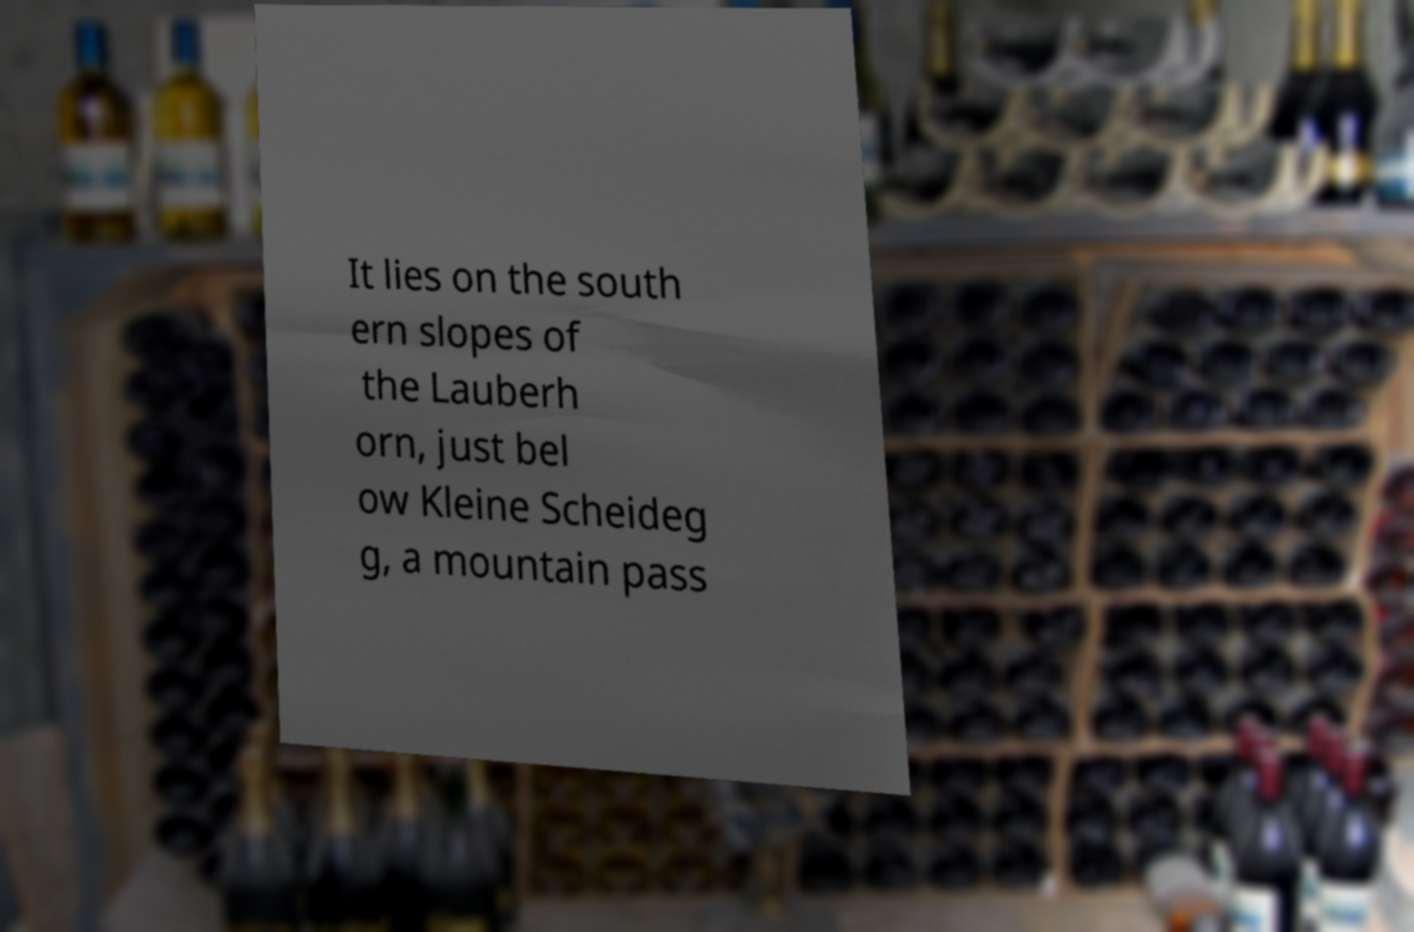Please read and relay the text visible in this image. What does it say? It lies on the south ern slopes of the Lauberh orn, just bel ow Kleine Scheideg g, a mountain pass 